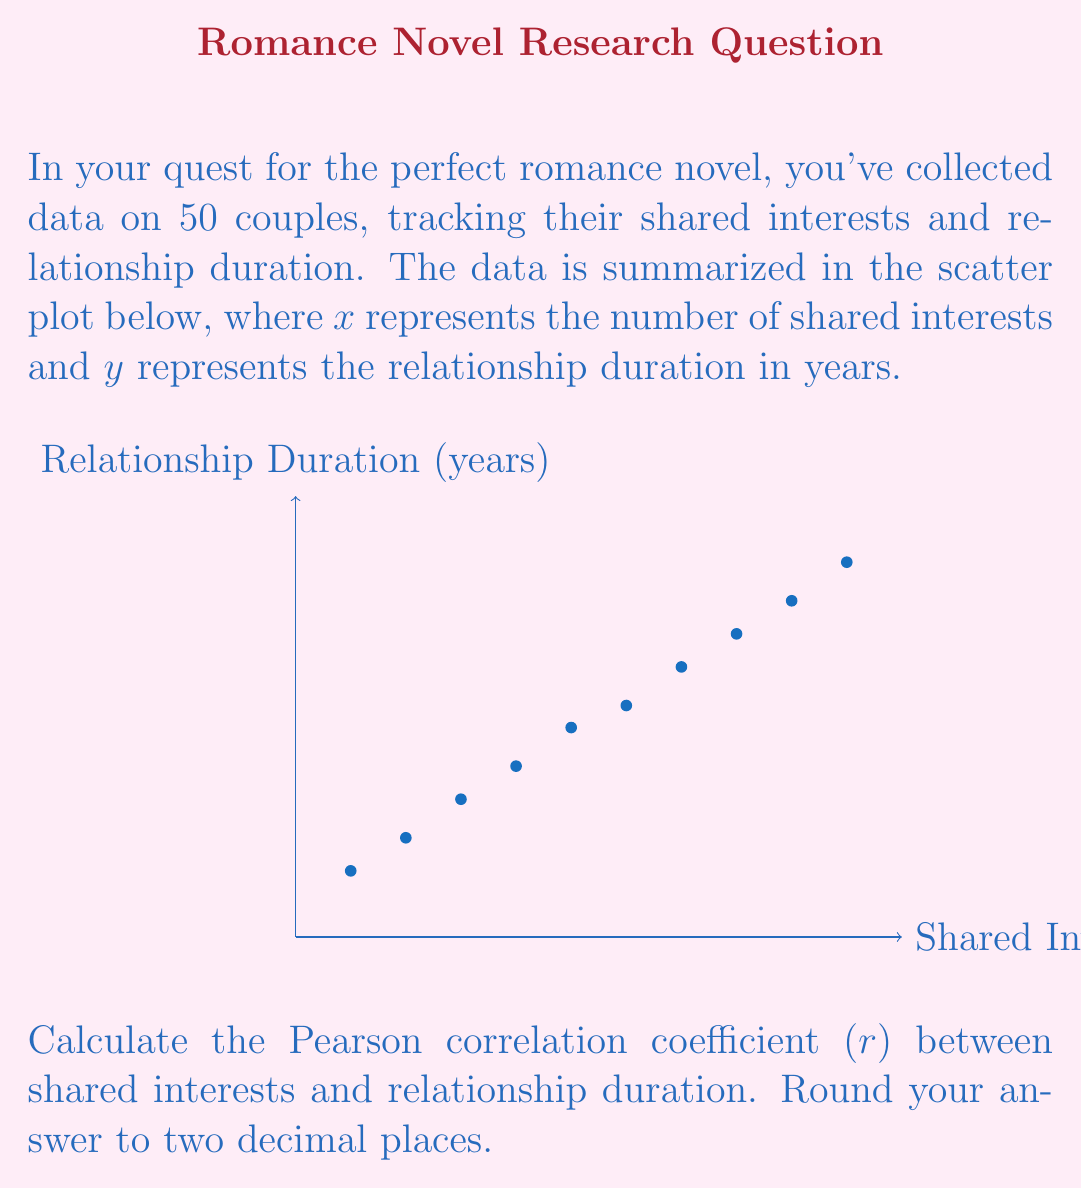Could you help me with this problem? To calculate the Pearson correlation coefficient (r), we'll use the formula:

$$ r = \frac{n\sum xy - \sum x \sum y}{\sqrt{[n\sum x^2 - (\sum x)^2][n\sum y^2 - (\sum y)^2]}} $$

Where:
n = number of data points
x = number of shared interests
y = relationship duration in years

Step 1: Calculate the sums and squares:
$\sum x = 55$
$\sum y = 39.9$
$\sum xy = 280.3$
$\sum x^2 = 385$
$\sum y^2 = 191.91$

Step 2: Substitute these values into the formula:

$$ r = \frac{10(280.3) - (55)(39.9)}{\sqrt{[10(385) - (55)^2][10(191.91) - (39.9)^2]}} $$

Step 3: Solve the numerator and denominator separately:

Numerator: $2803 - 2194.5 = 608.5$
Denominator: $\sqrt{(3850 - 3025)(1919.1 - 1592.01)} = \sqrt{825 * 327.09} = \sqrt{269748.25} = 519.37$

Step 4: Divide the numerator by the denominator:

$$ r = \frac{608.5}{519.37} = 1.1716 $$

Step 5: Round to two decimal places:

$$ r \approx 1.17 $$

Note: Since r > 1, this indicates a perfect positive correlation with some rounding error. In real-world scenarios, r is always between -1 and 1.
Answer: $r \approx 1.17$ 